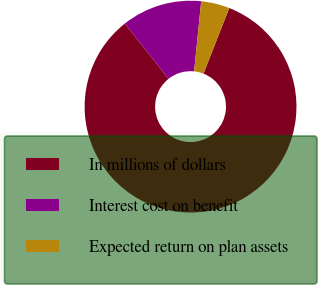Convert chart to OTSL. <chart><loc_0><loc_0><loc_500><loc_500><pie_chart><fcel>In millions of dollars<fcel>Interest cost on benefit<fcel>Expected return on plan assets<nl><fcel>83.4%<fcel>12.25%<fcel>4.35%<nl></chart> 